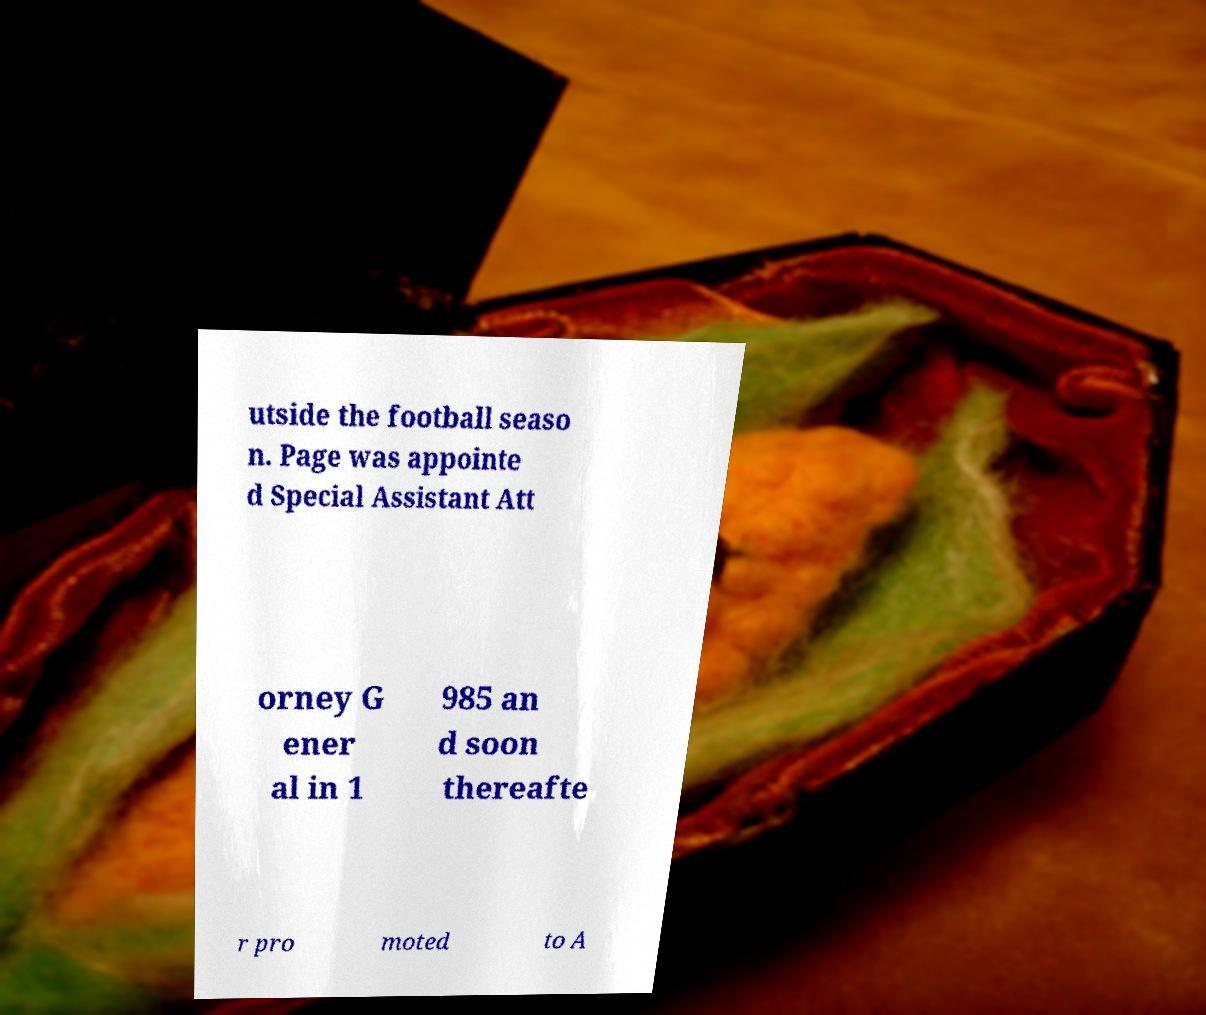What messages or text are displayed in this image? I need them in a readable, typed format. utside the football seaso n. Page was appointe d Special Assistant Att orney G ener al in 1 985 an d soon thereafte r pro moted to A 